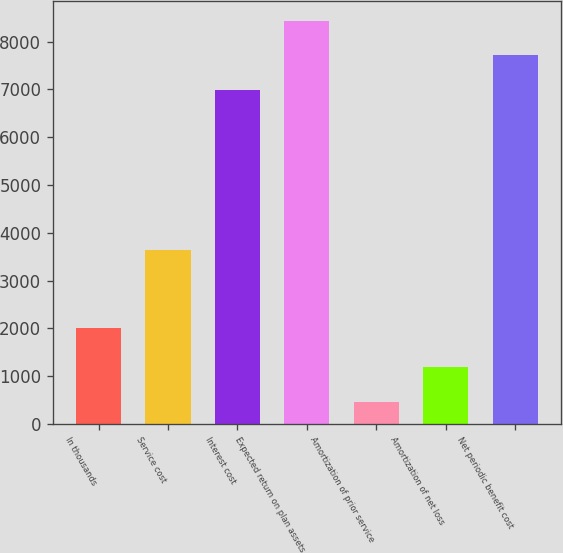Convert chart to OTSL. <chart><loc_0><loc_0><loc_500><loc_500><bar_chart><fcel>In thousands<fcel>Service cost<fcel>Interest cost<fcel>Expected return on plan assets<fcel>Amortization of prior service<fcel>Amortization of net loss<fcel>Net periodic benefit cost<nl><fcel>2007<fcel>3638<fcel>6992<fcel>8436.4<fcel>463<fcel>1185.2<fcel>7714.2<nl></chart> 